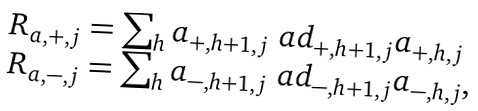Convert formula to latex. <formula><loc_0><loc_0><loc_500><loc_500>\begin{array} { l } R _ { a , + , j } = \sum _ { h } a _ { + , h + 1 , j } \ a d _ { + , h + 1 , j } a _ { + , h , j } \\ R _ { a , - , j } = \sum _ { h } a _ { - , h + 1 , j } \ a d _ { - , h + 1 , j } a _ { - , h , j } , \end{array}</formula> 